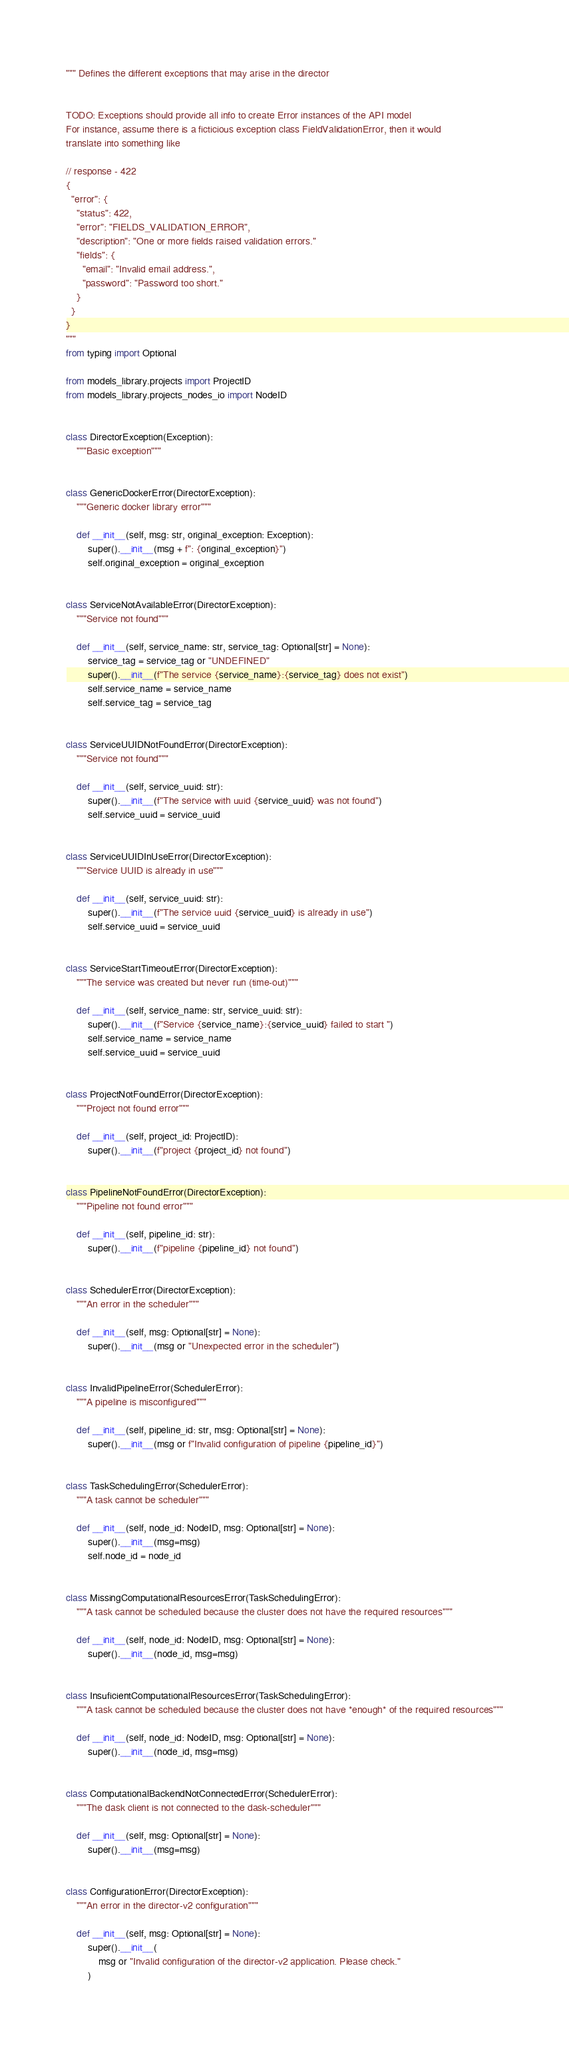Convert code to text. <code><loc_0><loc_0><loc_500><loc_500><_Python_>""" Defines the different exceptions that may arise in the director


TODO: Exceptions should provide all info to create Error instances of the API model
For instance, assume there is a ficticious exception class FieldValidationError, then it would
translate into something like

// response - 422
{
  "error": {
    "status": 422,
    "error": "FIELDS_VALIDATION_ERROR",
    "description": "One or more fields raised validation errors."
    "fields": {
      "email": "Invalid email address.",
      "password": "Password too short."
    }
  }
}
"""
from typing import Optional

from models_library.projects import ProjectID
from models_library.projects_nodes_io import NodeID


class DirectorException(Exception):
    """Basic exception"""


class GenericDockerError(DirectorException):
    """Generic docker library error"""

    def __init__(self, msg: str, original_exception: Exception):
        super().__init__(msg + f": {original_exception}")
        self.original_exception = original_exception


class ServiceNotAvailableError(DirectorException):
    """Service not found"""

    def __init__(self, service_name: str, service_tag: Optional[str] = None):
        service_tag = service_tag or "UNDEFINED"
        super().__init__(f"The service {service_name}:{service_tag} does not exist")
        self.service_name = service_name
        self.service_tag = service_tag


class ServiceUUIDNotFoundError(DirectorException):
    """Service not found"""

    def __init__(self, service_uuid: str):
        super().__init__(f"The service with uuid {service_uuid} was not found")
        self.service_uuid = service_uuid


class ServiceUUIDInUseError(DirectorException):
    """Service UUID is already in use"""

    def __init__(self, service_uuid: str):
        super().__init__(f"The service uuid {service_uuid} is already in use")
        self.service_uuid = service_uuid


class ServiceStartTimeoutError(DirectorException):
    """The service was created but never run (time-out)"""

    def __init__(self, service_name: str, service_uuid: str):
        super().__init__(f"Service {service_name}:{service_uuid} failed to start ")
        self.service_name = service_name
        self.service_uuid = service_uuid


class ProjectNotFoundError(DirectorException):
    """Project not found error"""

    def __init__(self, project_id: ProjectID):
        super().__init__(f"project {project_id} not found")


class PipelineNotFoundError(DirectorException):
    """Pipeline not found error"""

    def __init__(self, pipeline_id: str):
        super().__init__(f"pipeline {pipeline_id} not found")


class SchedulerError(DirectorException):
    """An error in the scheduler"""

    def __init__(self, msg: Optional[str] = None):
        super().__init__(msg or "Unexpected error in the scheduler")


class InvalidPipelineError(SchedulerError):
    """A pipeline is misconfigured"""

    def __init__(self, pipeline_id: str, msg: Optional[str] = None):
        super().__init__(msg or f"Invalid configuration of pipeline {pipeline_id}")


class TaskSchedulingError(SchedulerError):
    """A task cannot be scheduler"""

    def __init__(self, node_id: NodeID, msg: Optional[str] = None):
        super().__init__(msg=msg)
        self.node_id = node_id


class MissingComputationalResourcesError(TaskSchedulingError):
    """A task cannot be scheduled because the cluster does not have the required resources"""

    def __init__(self, node_id: NodeID, msg: Optional[str] = None):
        super().__init__(node_id, msg=msg)


class InsuficientComputationalResourcesError(TaskSchedulingError):
    """A task cannot be scheduled because the cluster does not have *enough* of the required resources"""

    def __init__(self, node_id: NodeID, msg: Optional[str] = None):
        super().__init__(node_id, msg=msg)


class ComputationalBackendNotConnectedError(SchedulerError):
    """The dask client is not connected to the dask-scheduler"""

    def __init__(self, msg: Optional[str] = None):
        super().__init__(msg=msg)


class ConfigurationError(DirectorException):
    """An error in the director-v2 configuration"""

    def __init__(self, msg: Optional[str] = None):
        super().__init__(
            msg or "Invalid configuration of the director-v2 application. Please check."
        )
</code> 